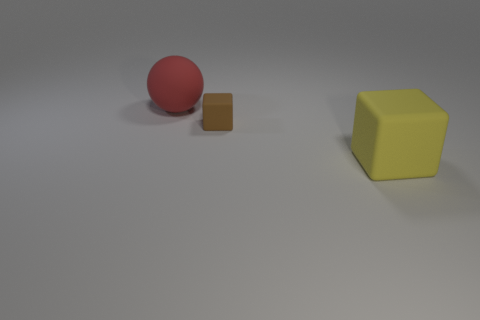Add 3 large cubes. How many objects exist? 6 Subtract all blocks. How many objects are left? 1 Add 3 large green objects. How many large green objects exist? 3 Subtract 1 red spheres. How many objects are left? 2 Subtract all tiny gray metal objects. Subtract all large red balls. How many objects are left? 2 Add 2 tiny brown cubes. How many tiny brown cubes are left? 3 